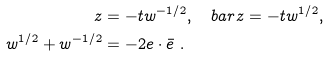<formula> <loc_0><loc_0><loc_500><loc_500>z & = - t w ^ { - 1 / 2 } , \quad b a r { z } = - t w ^ { 1 / 2 } , \\ w ^ { 1 / 2 } + w ^ { - 1 / 2 } & = - 2 { e } \cdot { \bar { e } } \ .</formula> 